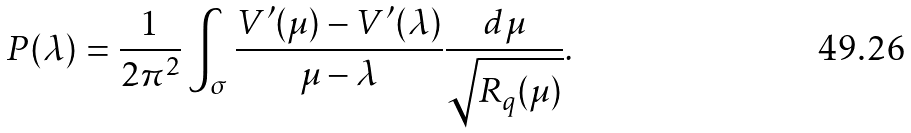Convert formula to latex. <formula><loc_0><loc_0><loc_500><loc_500>P ( \lambda ) = \frac { 1 } { 2 \pi ^ { 2 } } \int _ { \sigma } \frac { V ^ { \prime } ( \mu ) - V ^ { \prime } ( \lambda ) } { \mu - \lambda } \frac { d \mu } { \sqrt { R _ { q } ( \mu ) } } .</formula> 